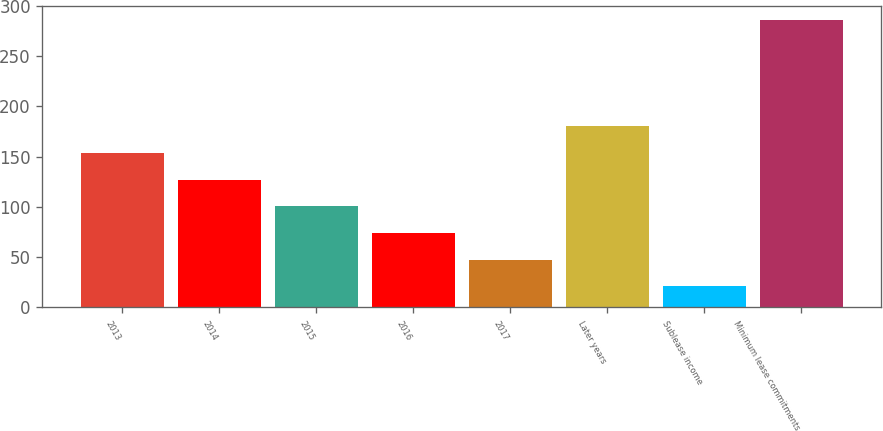<chart> <loc_0><loc_0><loc_500><loc_500><bar_chart><fcel>2013<fcel>2014<fcel>2015<fcel>2016<fcel>2017<fcel>Later years<fcel>Sublease income<fcel>Minimum lease commitments<nl><fcel>153.5<fcel>127<fcel>100.5<fcel>74<fcel>47.5<fcel>180<fcel>21<fcel>286<nl></chart> 